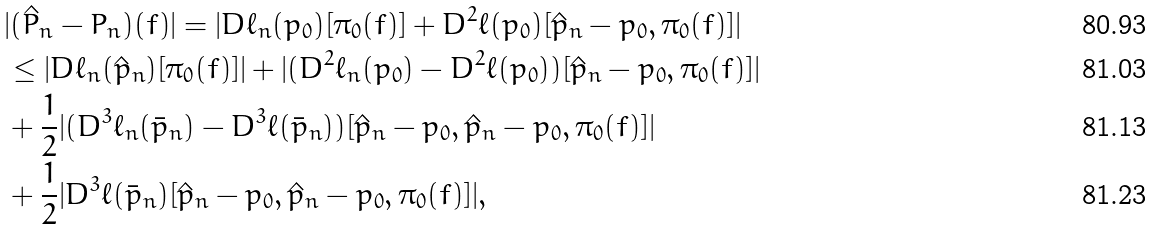Convert formula to latex. <formula><loc_0><loc_0><loc_500><loc_500>& | ( \hat { P } _ { n } - P _ { n } ) ( f ) | = | D \ell _ { n } ( p _ { 0 } ) [ \pi _ { 0 } ( f ) ] + D ^ { 2 } \ell ( p _ { 0 } ) [ \hat { p } _ { n } - p _ { 0 } , \pi _ { 0 } ( f ) ] | \\ & \leq | D \ell _ { n } ( \hat { p } _ { n } ) [ \pi _ { 0 } ( f ) ] | + | ( D ^ { 2 } \ell _ { n } ( p _ { 0 } ) - D ^ { 2 } \ell ( p _ { 0 } ) ) [ \hat { p } _ { n } - p _ { 0 } , \pi _ { 0 } ( f ) ] | \\ & + \frac { 1 } { 2 } | ( D ^ { 3 } \ell _ { n } ( \bar { p } _ { n } ) - D ^ { 3 } \ell ( \bar { p } _ { n } ) ) [ \hat { p } _ { n } - p _ { 0 } , \hat { p } _ { n } - p _ { 0 } , \pi _ { 0 } ( f ) ] | \\ & + \frac { 1 } { 2 } | D ^ { 3 } \ell ( \bar { p } _ { n } ) [ \hat { p } _ { n } - p _ { 0 } , \hat { p } _ { n } - p _ { 0 } , \pi _ { 0 } ( f ) ] | ,</formula> 